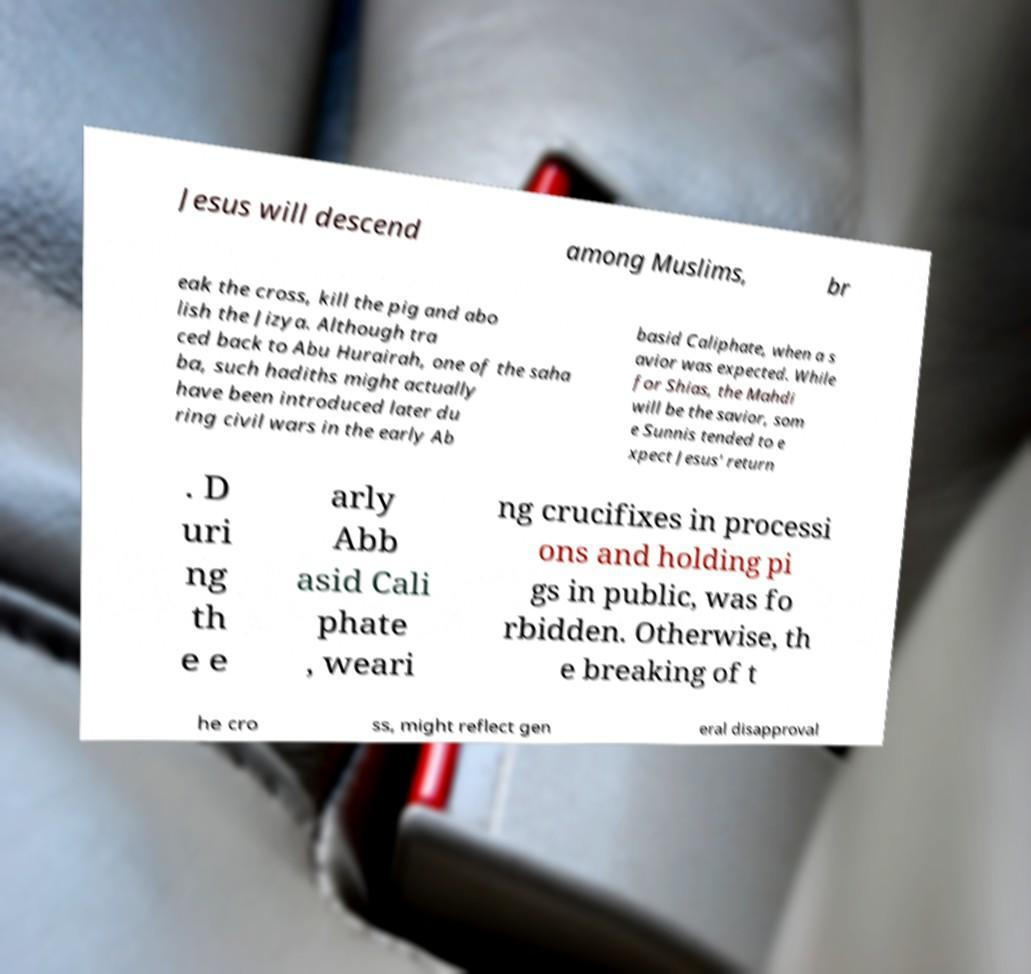Can you read and provide the text displayed in the image?This photo seems to have some interesting text. Can you extract and type it out for me? Jesus will descend among Muslims, br eak the cross, kill the pig and abo lish the Jizya. Although tra ced back to Abu Hurairah, one of the saha ba, such hadiths might actually have been introduced later du ring civil wars in the early Ab basid Caliphate, when a s avior was expected. While for Shias, the Mahdi will be the savior, som e Sunnis tended to e xpect Jesus' return . D uri ng th e e arly Abb asid Cali phate , weari ng crucifixes in processi ons and holding pi gs in public, was fo rbidden. Otherwise, th e breaking of t he cro ss, might reflect gen eral disapproval 